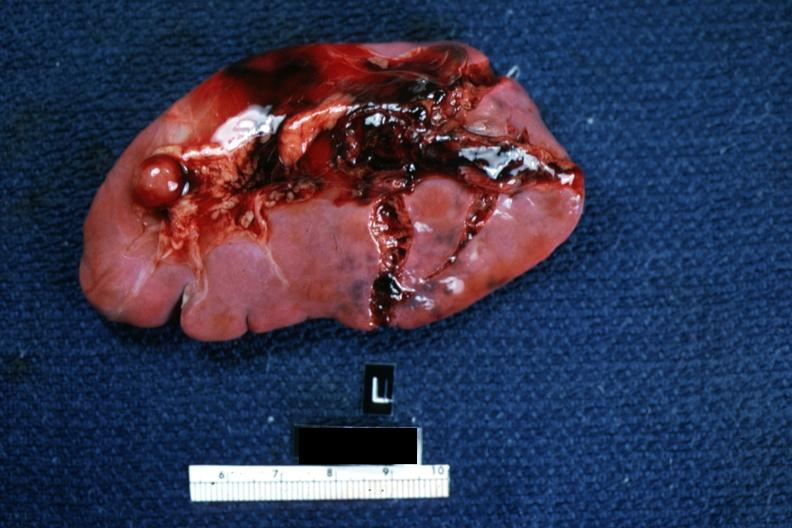what is present?
Answer the question using a single word or phrase. Hematologic 